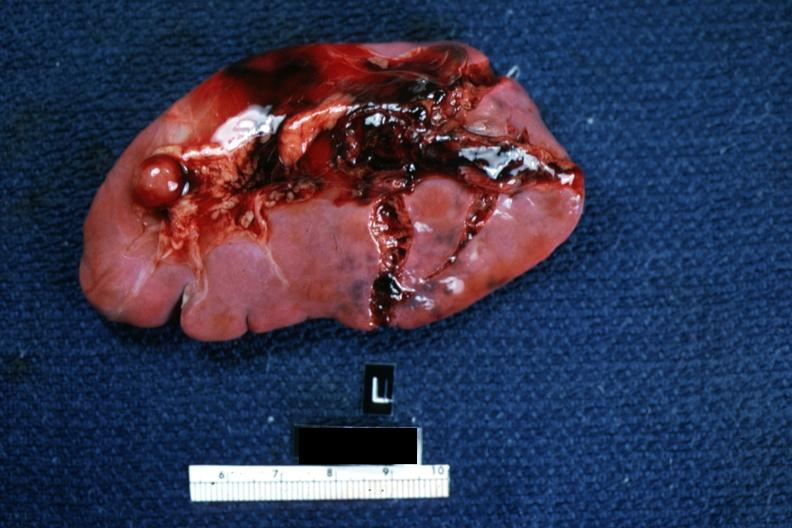what is present?
Answer the question using a single word or phrase. Hematologic 